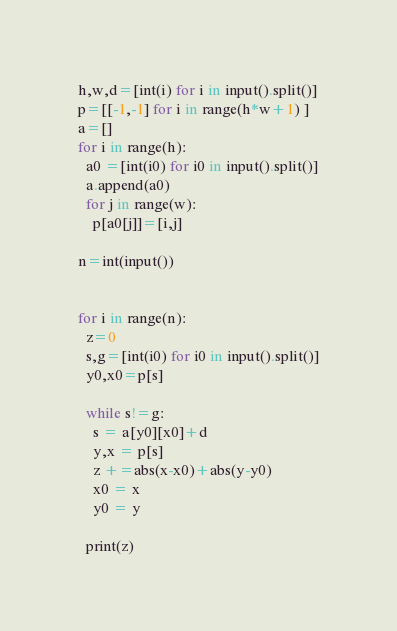Convert code to text. <code><loc_0><loc_0><loc_500><loc_500><_Python_>h,w,d=[int(i) for i in input().split()]
p=[[-1,-1] for i in range(h*w+1) ]
a=[]
for i in range(h):
  a0 =[int(i0) for i0 in input().split()]
  a.append(a0)
  for j in range(w):
    p[a0[j]]=[i,j]

n=int(input())


for i in range(n):
  z=0
  s,g=[int(i0) for i0 in input().split()]
  y0,x0=p[s]
  
  while s!=g:
    s = a[y0][x0]+d
    y,x = p[s]
    z +=abs(x-x0)+abs(y-y0)
    x0 = x
    y0 = y

  print(z)</code> 